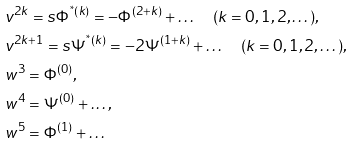Convert formula to latex. <formula><loc_0><loc_0><loc_500><loc_500>& v ^ { 2 k } = s \Phi ^ { ^ { * } ( k ) } = - \Phi ^ { ( 2 + k ) } + \dots \quad ( k = 0 , 1 , 2 , \dots ) , \\ & v ^ { 2 k + 1 } = s \Psi ^ { ^ { * } ( k ) } = - 2 \Psi ^ { ( 1 + k ) } + \dots \quad ( k = 0 , 1 , 2 , \dots ) , \\ & w ^ { 3 } = \Phi ^ { ( 0 ) } , \\ & w ^ { 4 } = \Psi ^ { ( 0 ) } + \dots , \\ & w ^ { 5 } = \Phi ^ { ( 1 ) } + \dots</formula> 